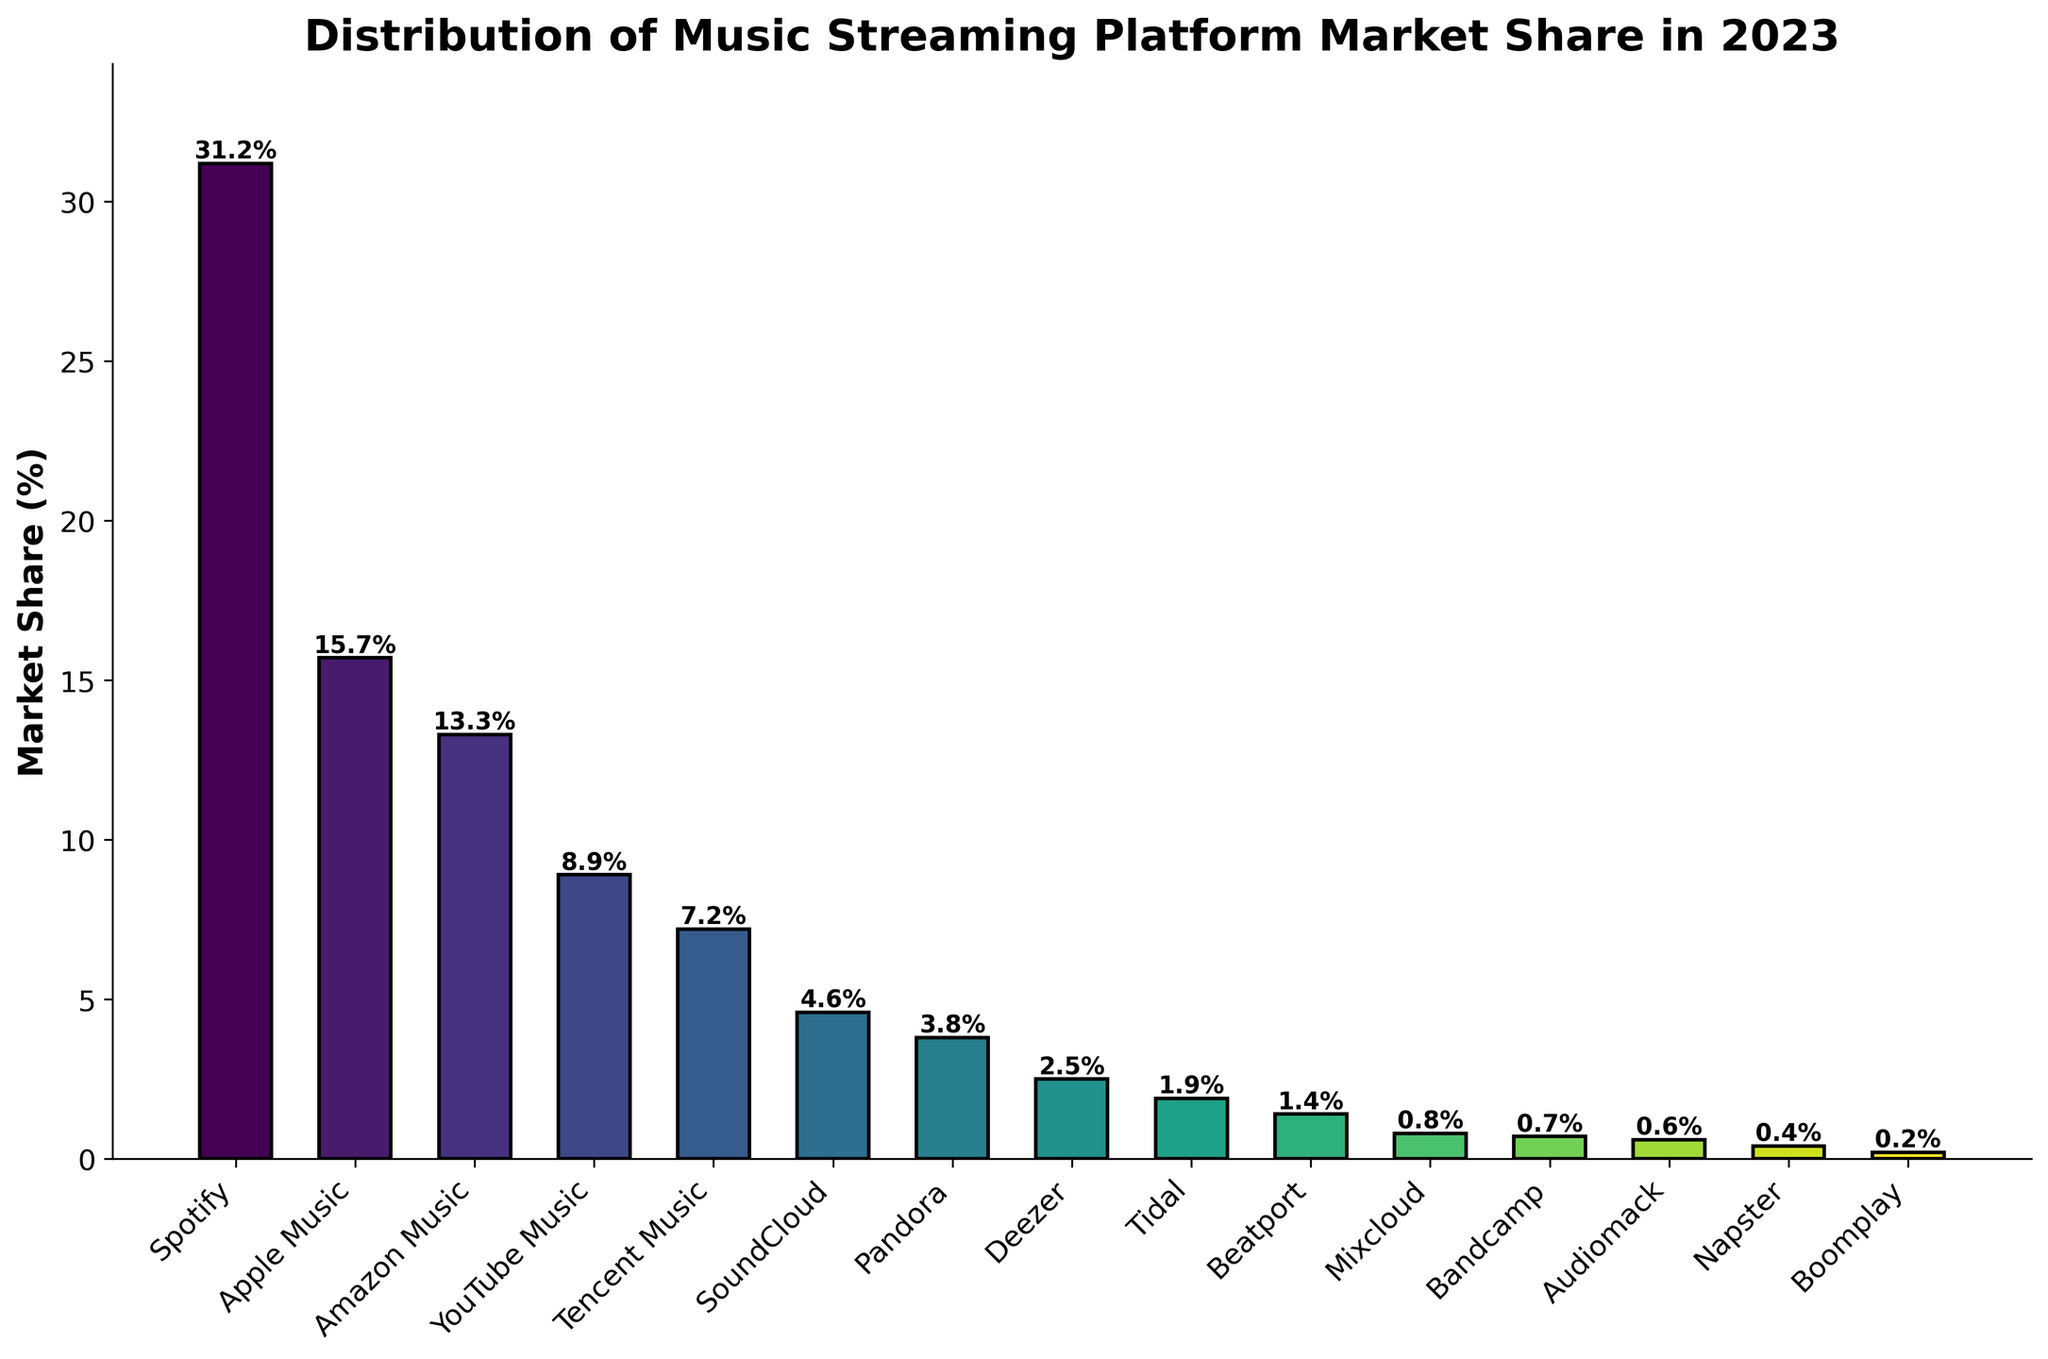what is the market share of the leading platform? Identify the bar with the highest height and check the label below it, which corresponds to Spotify with a market share of 31.2%.
Answer: 31.2% Which platform has the smallest market share? Identify the shortest bar and check the label below it, which corresponds to Boomplay with a market share of 0.2%.
Answer: Boomplay What is the combined market share of Apple Music and Amazon Music? Add the market shares of Apple Music (15.7%) and Amazon Music (13.3%) to get the combined market share: 15.7% + 13.3% = 29.0%.
Answer: 29.0% How much greater is Spotify's market share compared to Apple Music's? Subtract Apple Music's market share (15.7%) from Spotify's market share (31.2%): 31.2% - 15.7% = 15.5%.
Answer: 15.5% What fraction of the total market do SoundCloud and Pandora collectively hold? Add the market shares of SoundCloud (4.6%) and Pandora (3.8%) to get their combined share: 4.6% + 3.8% = 8.4%.
Answer: 8.4% Which platforms have a market share below 2%? Identify the bars with heights less than 2% and check their labels, corresponding to Tidal (1.9%), Beatport (1.4%), Mixcloud (0.8%), Bandcamp (0.7%), Audiomack (0.6%), Napster (0.4%), and Boomplay (0.2%).
Answer: Tidal, Beatport, Mixcloud, Bandcamp, Audiomack, Napster, Boomplay By how much does YouTube Music's market share exceed that of Tencent Music? Subtract Tencent Music's market share (7.2%) from YouTube Music's market share (8.9%): 8.9% - 7.2% = 1.7%.
Answer: 1.7% What is the total market share of the top three platforms combined? Add the market shares of Spotify (31.2%), Apple Music (15.7%), and Amazon Music (13.3%) to get the total: 31.2% + 15.7% + 13.3% = 60.2%.
Answer: 60.2% Which platform has a height approximately half that of Spotify's? Since Spotify's market share is 31.2%, half of that is about 15.6%. Apple Music with 15.7% is the closest to this value.
Answer: Apple Music Are there more platforms with market shares above 10% or below 1%? Platforms above 10%: Spotify, Apple Music, Amazon Music (3 platforms). Platforms below 1%: Mixcloud, Bandcamp, Audiomack, Napster, Boomplay (5 platforms). Therefore, there are more platforms with market shares below 1%.
Answer: Below 1% 